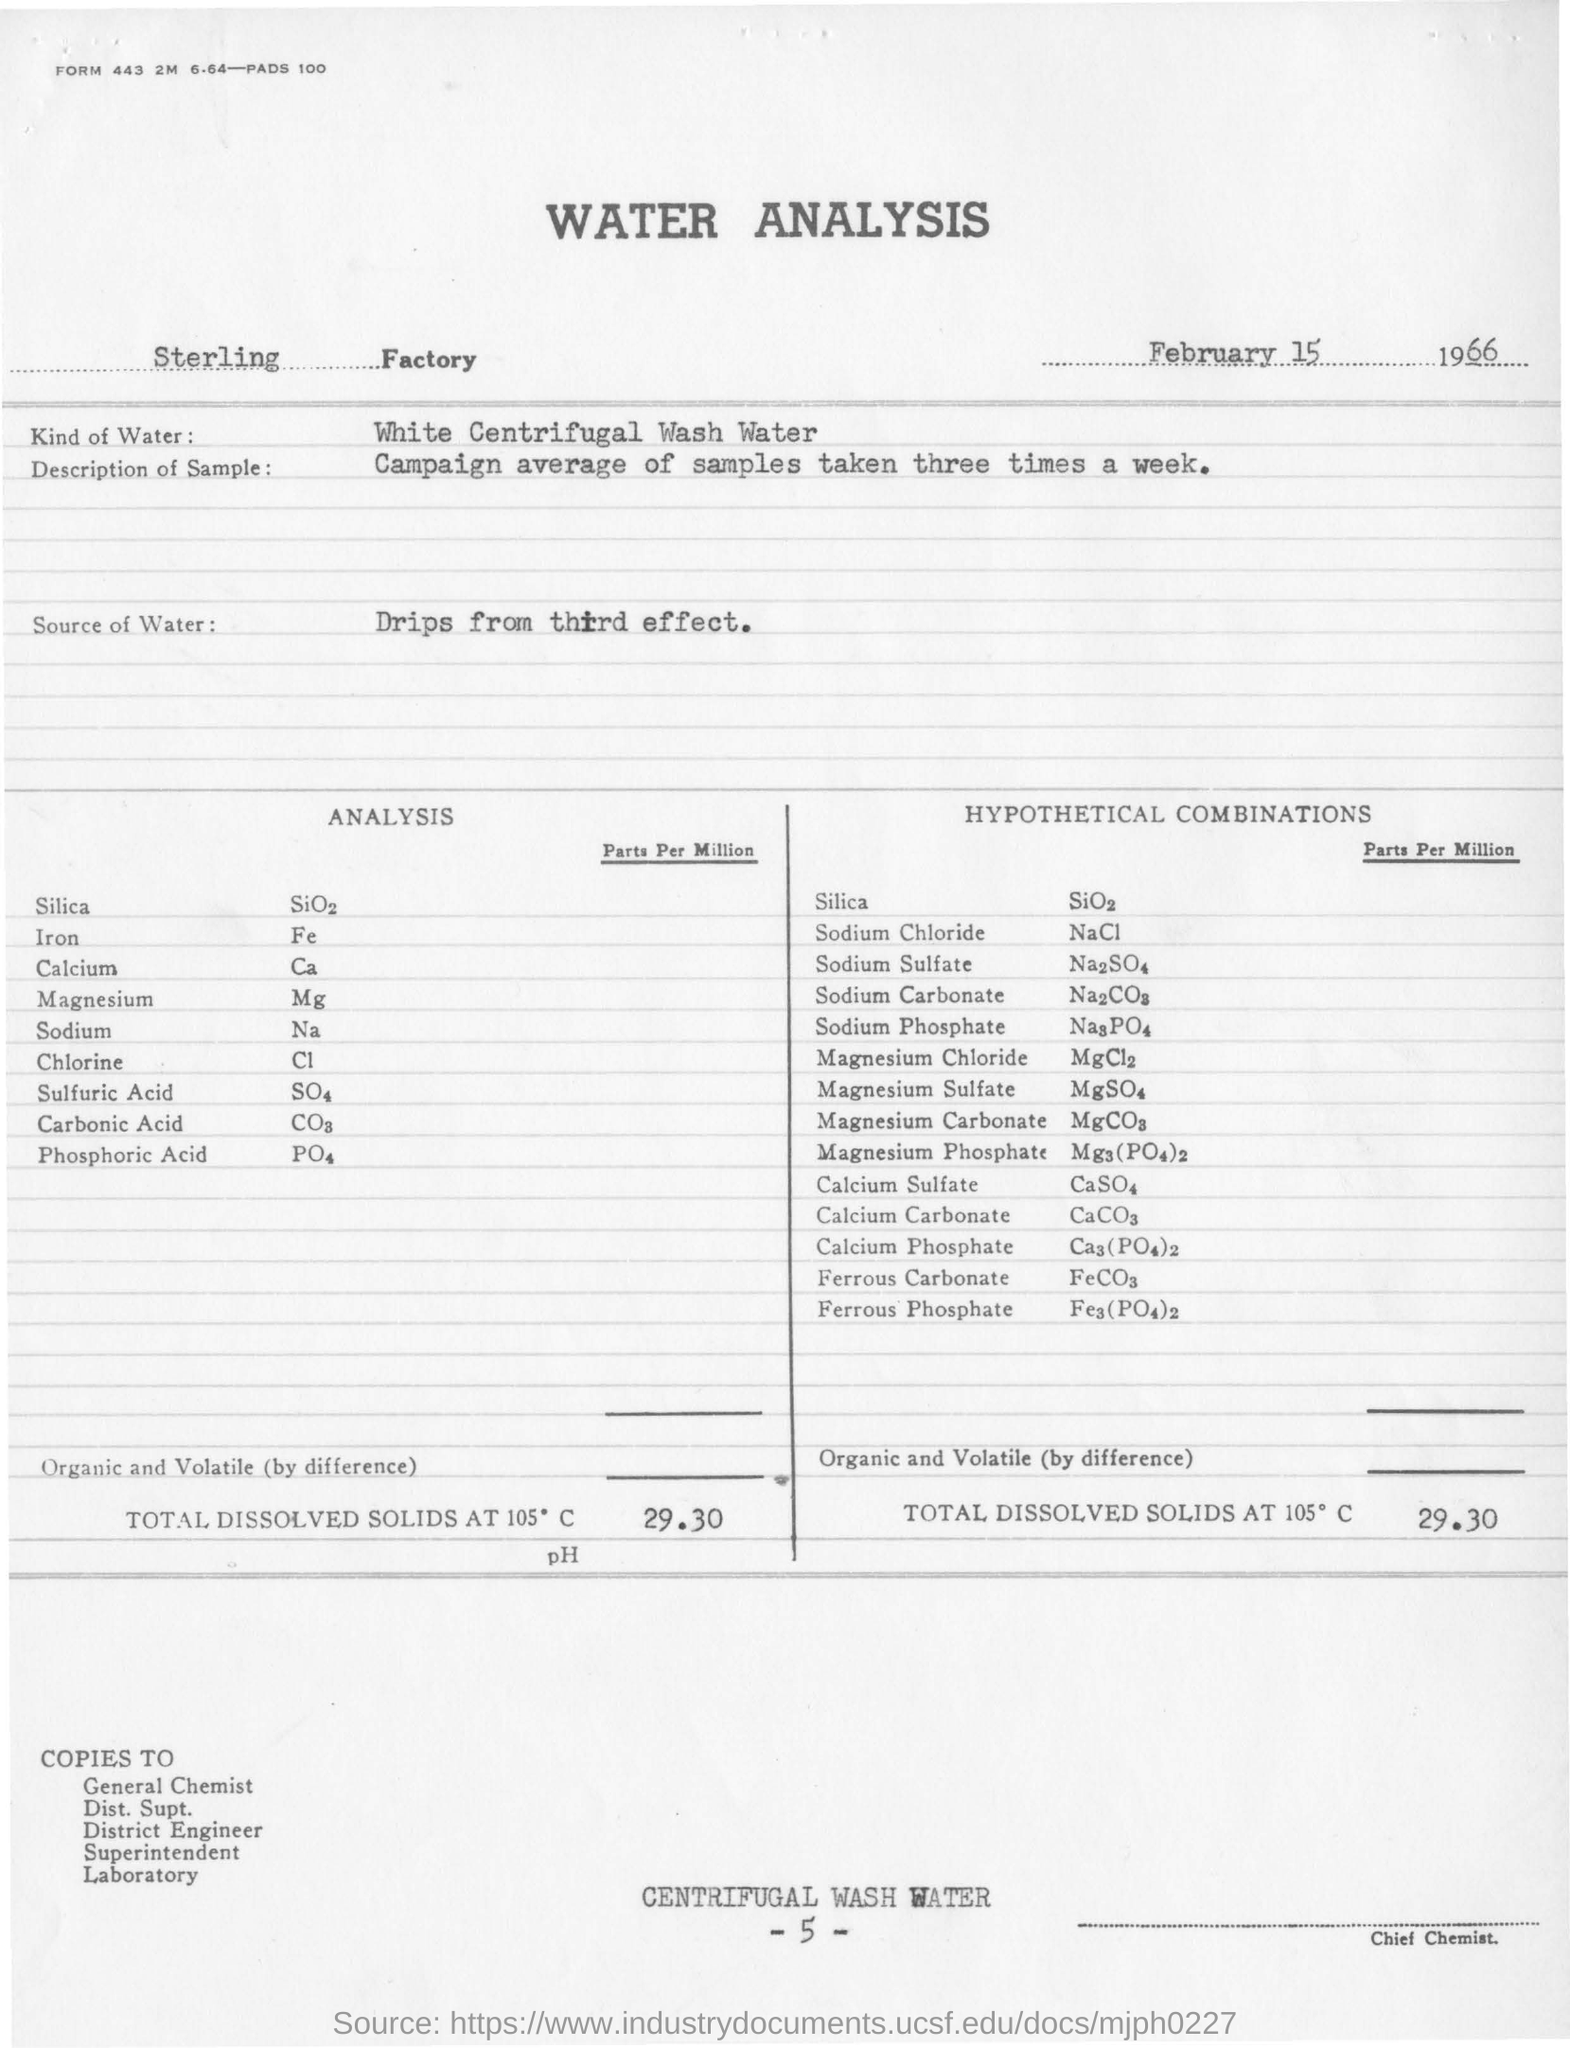Wha is the date of the report?
Your response must be concise. FEBRUARY 15, 1966. What kind of water was used for the analysis?
Your answer should be compact. White Centrifugal Wash Water. How many times the samples were taken for analysis?
Give a very brief answer. Three times a week. 